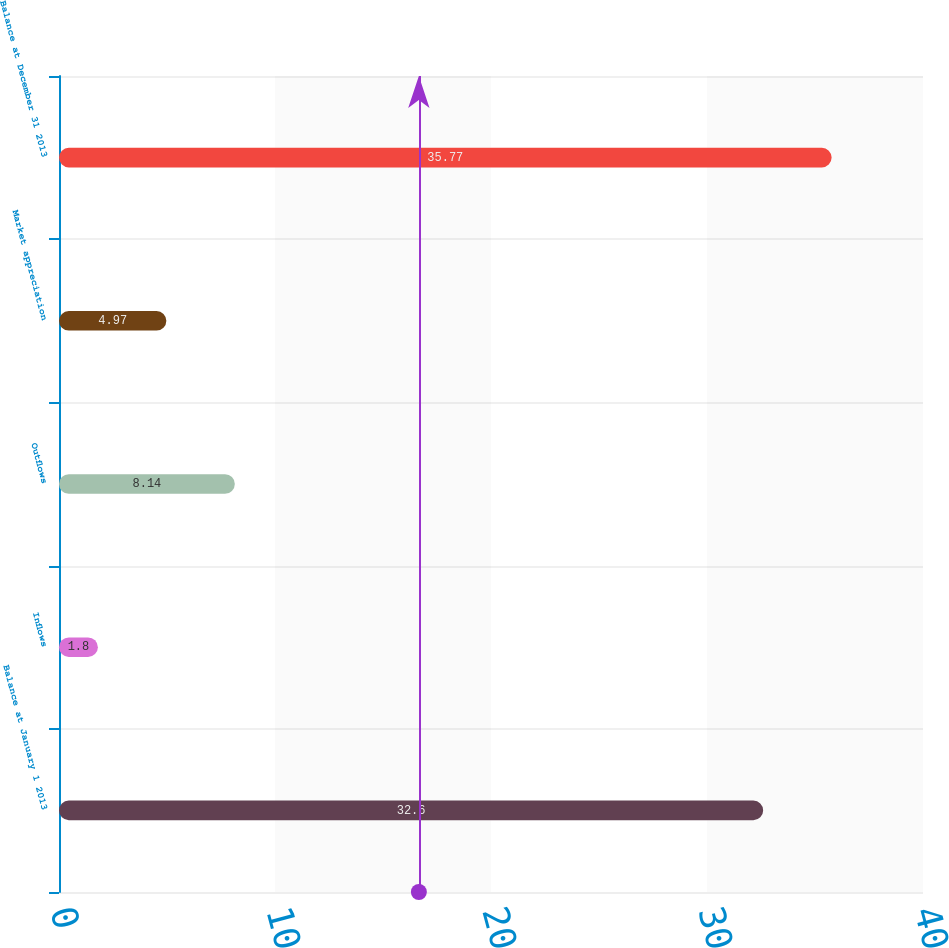Convert chart. <chart><loc_0><loc_0><loc_500><loc_500><bar_chart><fcel>Balance at January 1 2013<fcel>Inflows<fcel>Outflows<fcel>Market appreciation<fcel>Balance at December 31 2013<nl><fcel>32.6<fcel>1.8<fcel>8.14<fcel>4.97<fcel>35.77<nl></chart> 